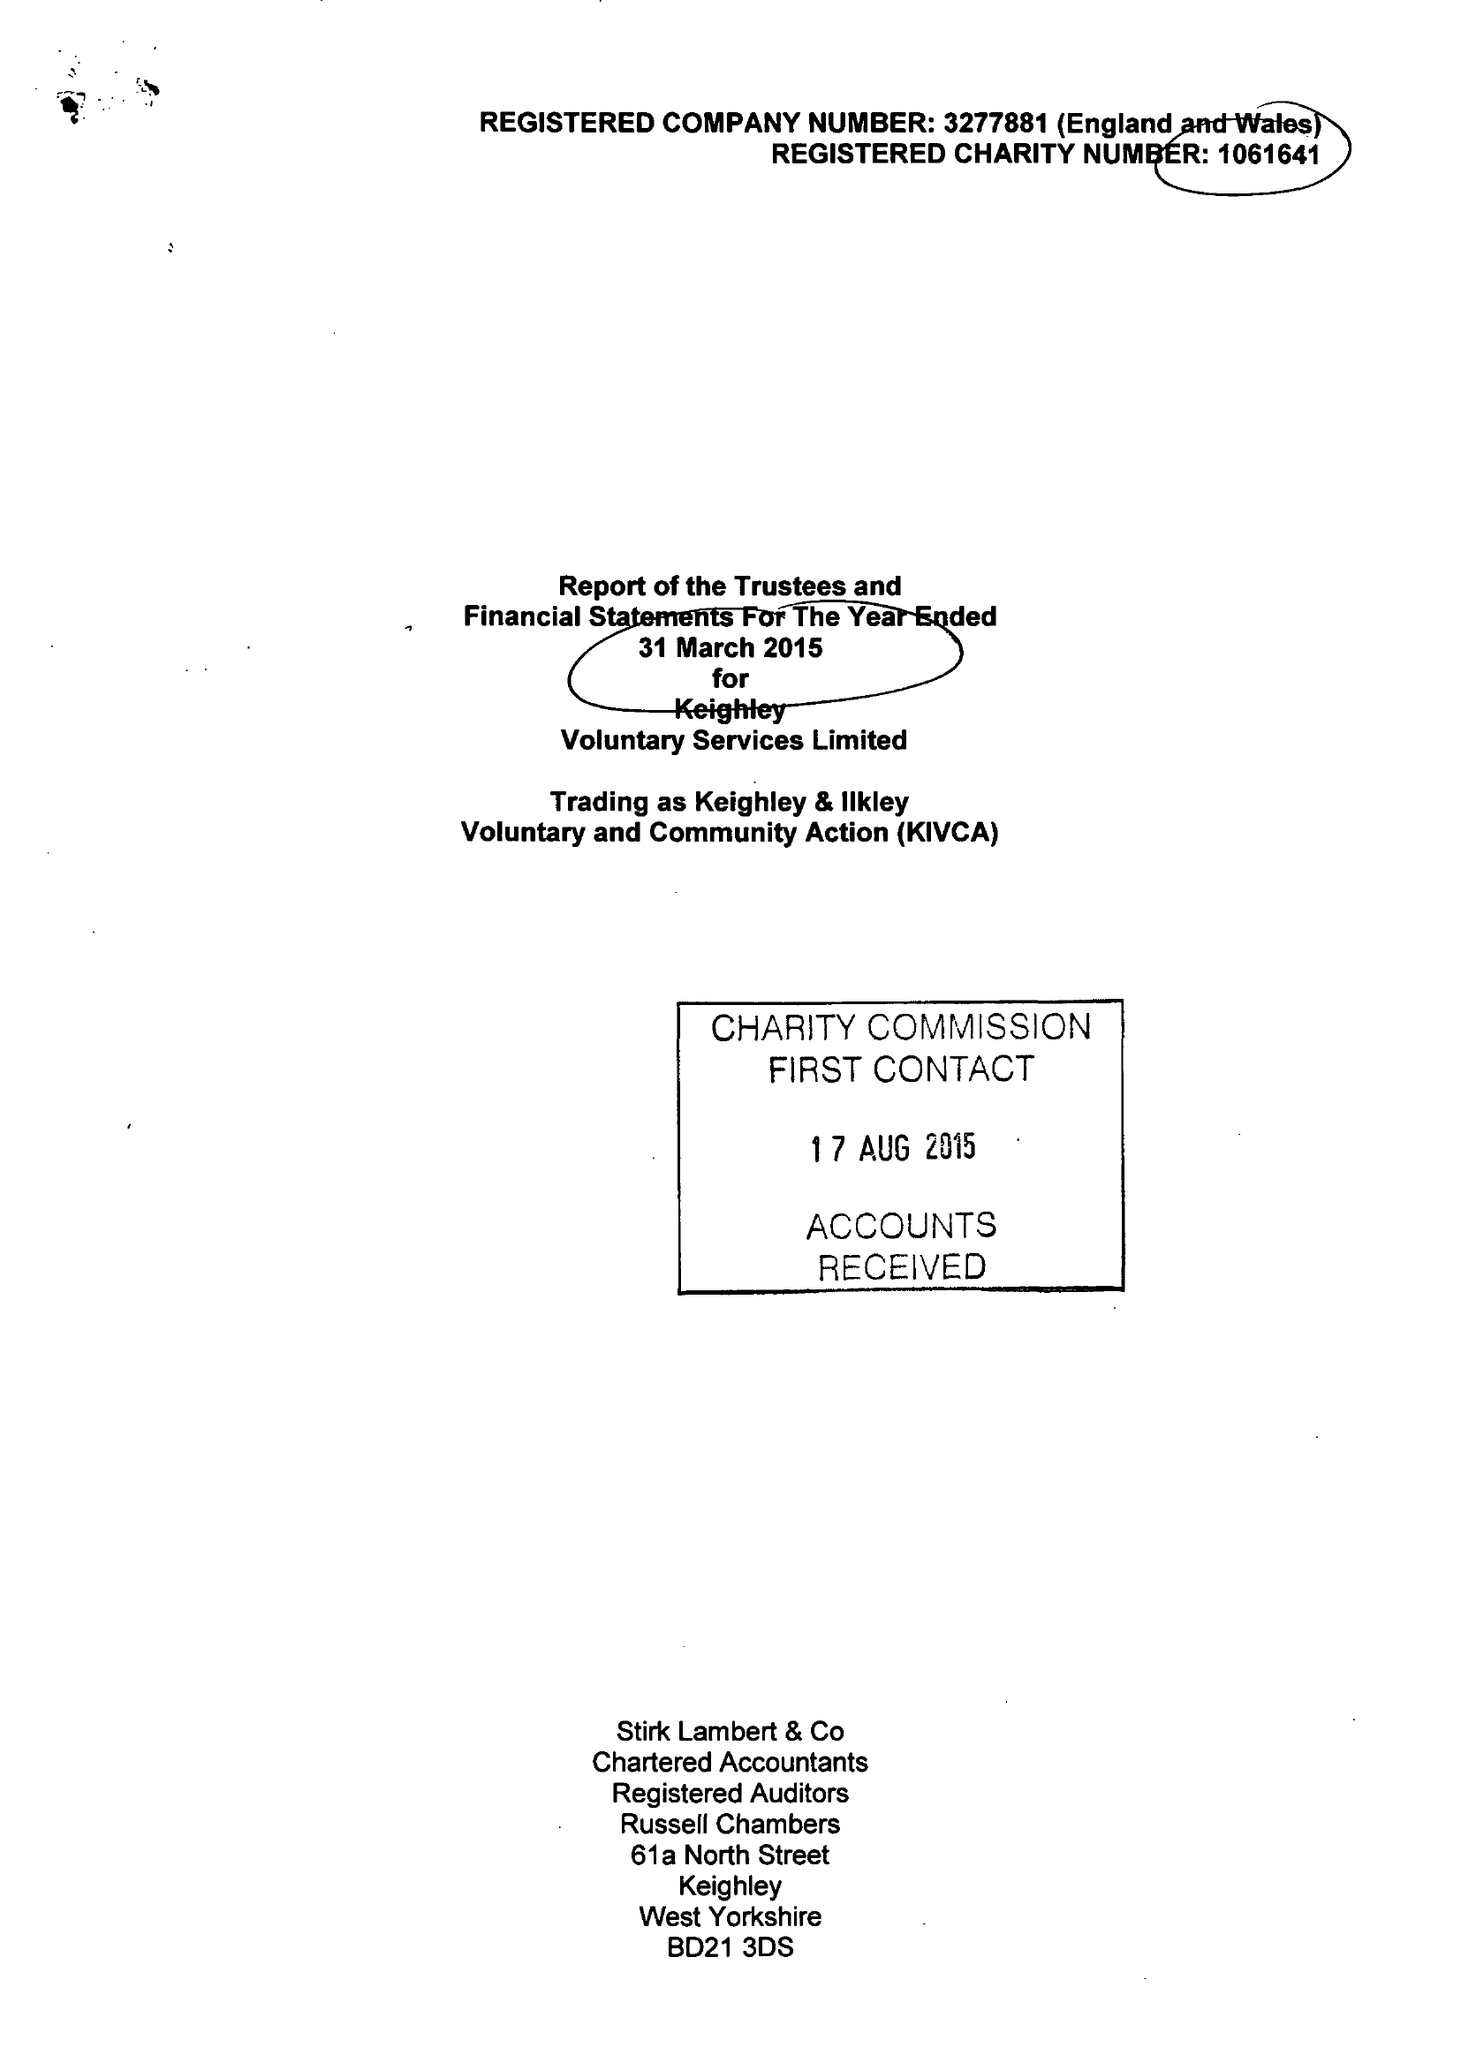What is the value for the charity_number?
Answer the question using a single word or phrase. 1061641 